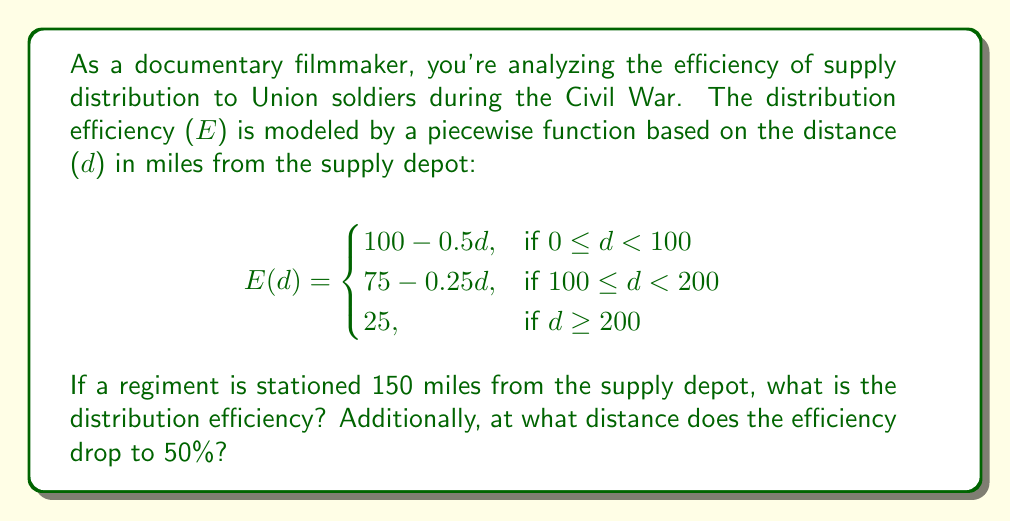Help me with this question. Let's approach this problem step-by-step:

1. First, we need to determine which piece of the function applies when d = 150 miles:
   $100 \leq 150 < 200$, so we use the second piece of the function.

2. Calculate the efficiency at 150 miles:
   $E(150) = 75 - 0.25(150) = 75 - 37.5 = 37.5$

3. To find where the efficiency drops to 50%, we need to solve each piece of the function for d when E(d) = 50:

   For $0 \leq d < 100$:
   $50 = 100 - 0.5d$
   $0.5d = 50$
   $d = 100$

   For $100 \leq d < 200$:
   $50 = 75 - 0.25d$
   $0.25d = 25$
   $d = 100$

   For $d \geq 200$:
   The efficiency is always 25, which is less than 50.

4. The efficiency drops to 50% at exactly 100 miles, which is the boundary between the first and second pieces of the function.
Answer: 37.5%; 100 miles 